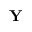<formula> <loc_0><loc_0><loc_500><loc_500>\mathbf Y</formula> 